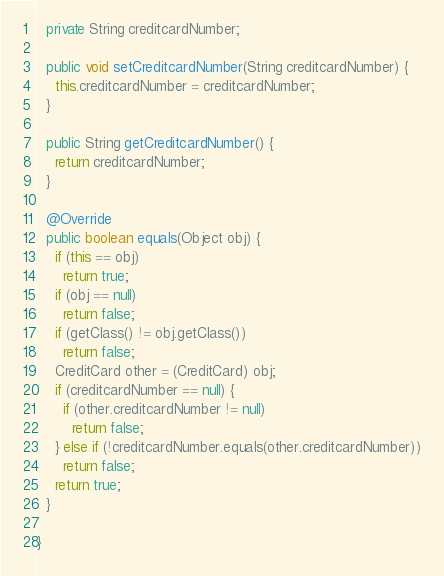<code> <loc_0><loc_0><loc_500><loc_500><_Java_>
  private String creditcardNumber;

  public void setCreditcardNumber(String creditcardNumber) {
    this.creditcardNumber = creditcardNumber;
  }

  public String getCreditcardNumber() {
    return creditcardNumber;
  }

  @Override
  public boolean equals(Object obj) {
    if (this == obj)
      return true;
    if (obj == null)
      return false;
    if (getClass() != obj.getClass())
      return false;
    CreditCard other = (CreditCard) obj;
    if (creditcardNumber == null) {
      if (other.creditcardNumber != null)
        return false;
    } else if (!creditcardNumber.equals(other.creditcardNumber))
      return false;
    return true;
  }

}
</code> 